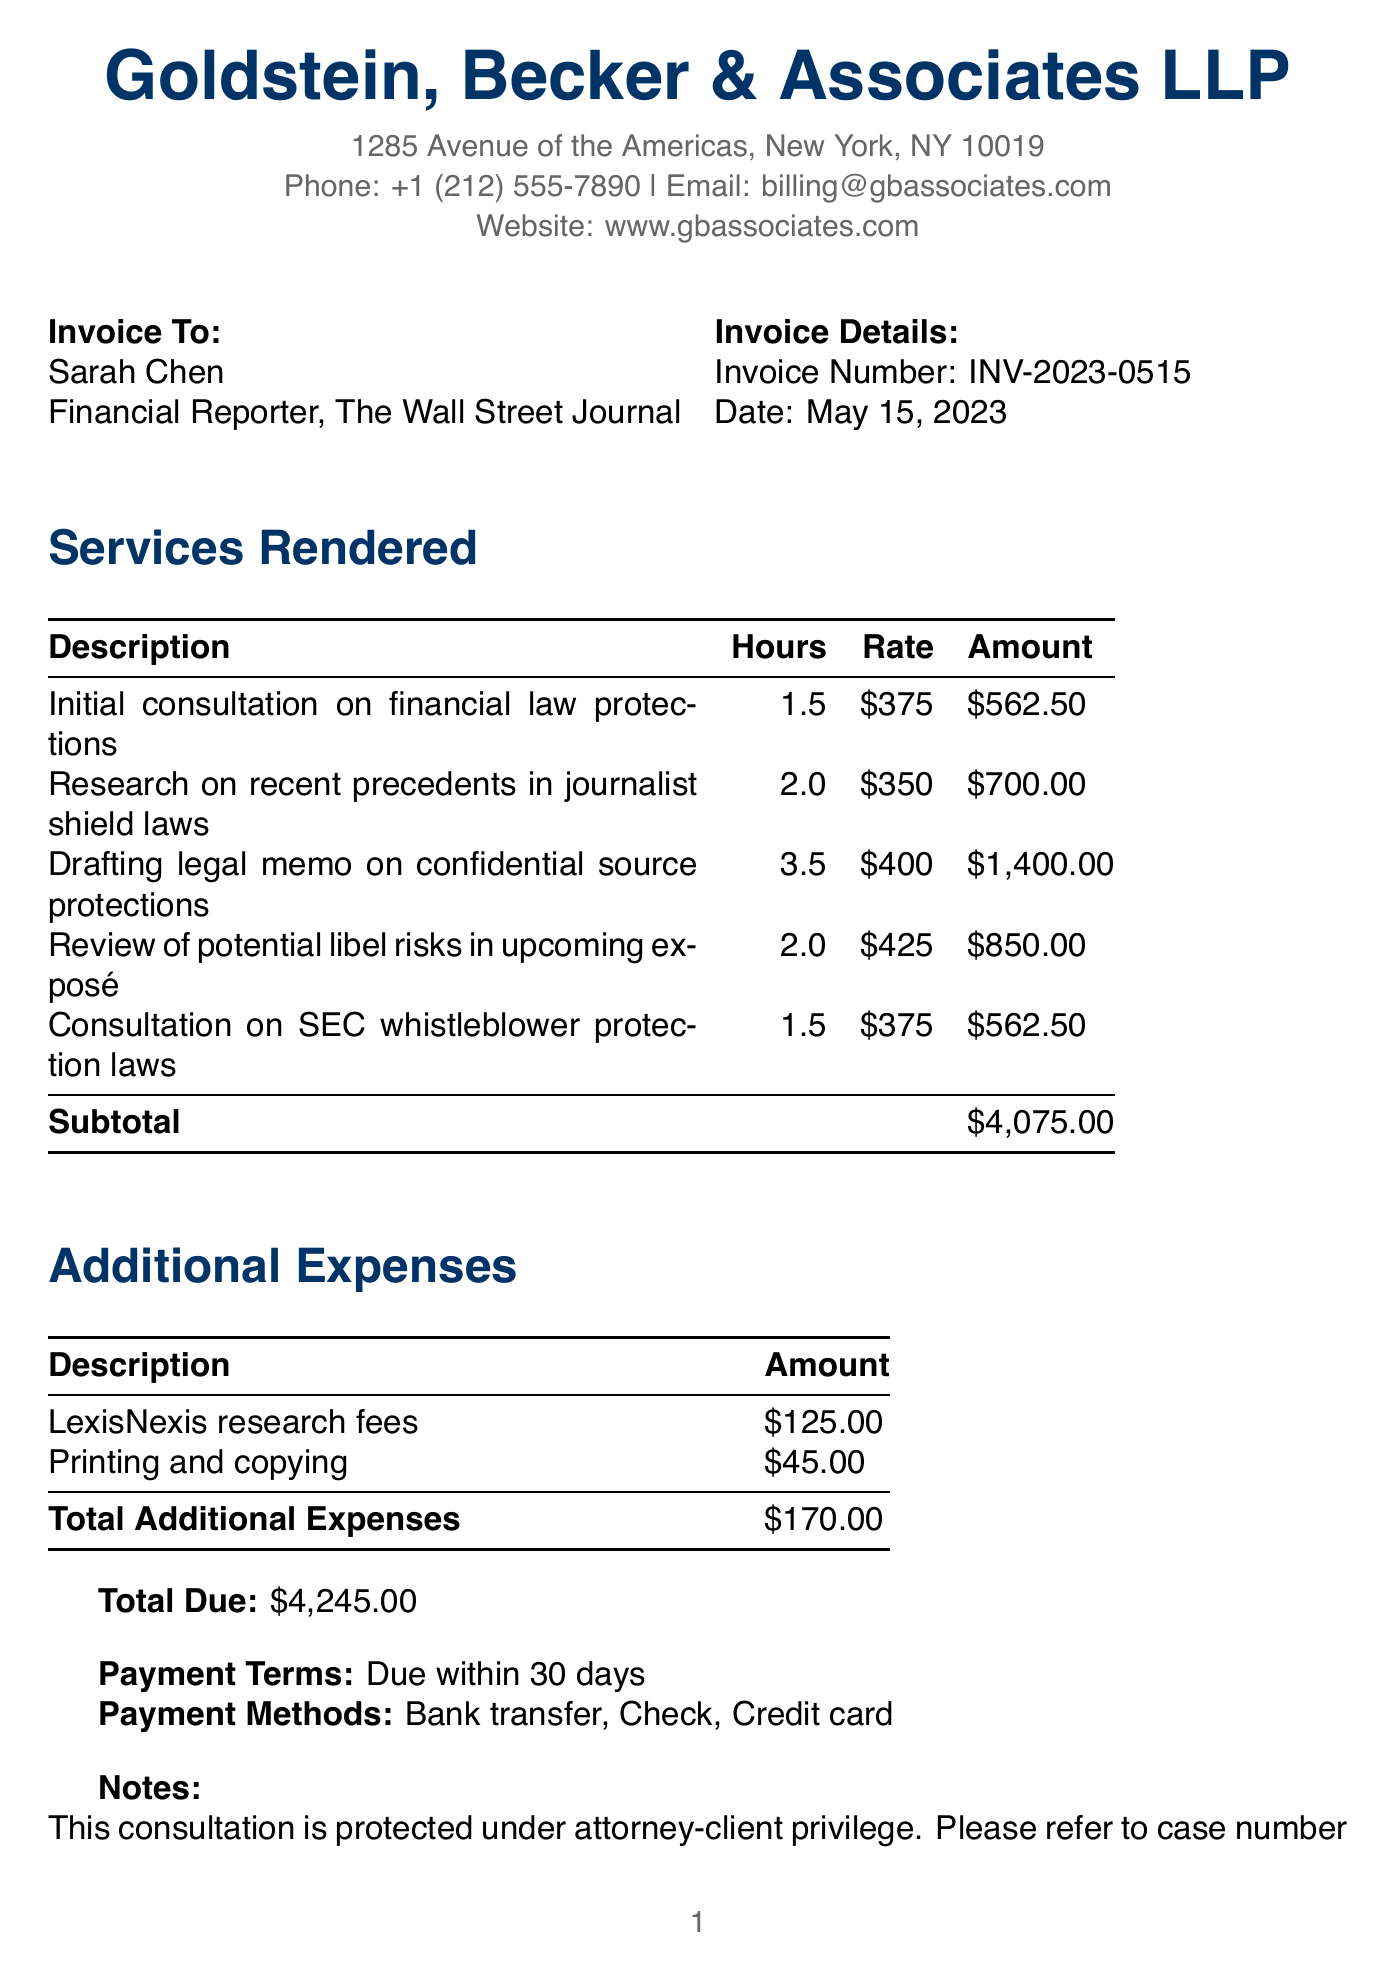What is the name of the legal firm? The name of the legal firm is provided at the top of the document.
Answer: Goldstein, Becker & Associates LLP Who is the client? The client’s name is mentioned in the invoice details section of the document.
Answer: Sarah Chen What is the invoice number? The invoice number is stated clearly in the invoice details section.
Answer: INV-2023-0515 How many hours were billed for drafting the legal memo? The hours for this service can be found in the services rendered section of the document.
Answer: 3.5 What is the total amount due? The total amount due is calculated and stated at the end of the document.
Answer: $4,245.00 What expense is associated with LexisNexis? This expense is listed in the additional expenses section of the document.
Answer: LexisNexis research fees How long does the client have to pay the invoice? This information is found near the end of the document under payment terms.
Answer: 30 days What is one of the payment methods accepted? The payment methods are listed towards the end of the document.
Answer: Bank transfer What is the purpose of the consultation according to the notes? The purpose is mentioned in the notes section that summarizes the document's protections.
Answer: protected under attorney-client privilege 